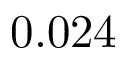<formula> <loc_0><loc_0><loc_500><loc_500>0 . 0 2 4</formula> 